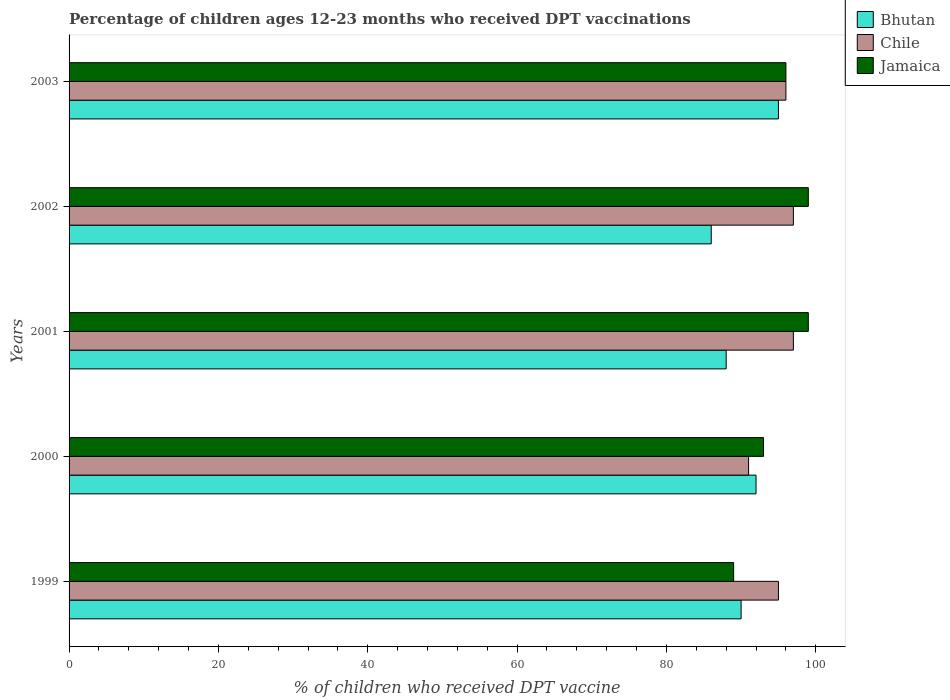How many groups of bars are there?
Offer a terse response. 5. How many bars are there on the 5th tick from the top?
Give a very brief answer. 3. What is the percentage of children who received DPT vaccination in Jamaica in 2001?
Your answer should be compact. 99. Across all years, what is the maximum percentage of children who received DPT vaccination in Jamaica?
Ensure brevity in your answer.  99. Across all years, what is the minimum percentage of children who received DPT vaccination in Chile?
Make the answer very short. 91. In which year was the percentage of children who received DPT vaccination in Bhutan maximum?
Your answer should be very brief. 2003. In which year was the percentage of children who received DPT vaccination in Jamaica minimum?
Your answer should be compact. 1999. What is the total percentage of children who received DPT vaccination in Chile in the graph?
Keep it short and to the point. 476. What is the difference between the percentage of children who received DPT vaccination in Bhutan in 1999 and that in 2000?
Offer a terse response. -2. What is the difference between the percentage of children who received DPT vaccination in Jamaica in 2001 and the percentage of children who received DPT vaccination in Chile in 2003?
Your answer should be compact. 3. What is the average percentage of children who received DPT vaccination in Bhutan per year?
Ensure brevity in your answer.  90.2. In the year 2001, what is the difference between the percentage of children who received DPT vaccination in Bhutan and percentage of children who received DPT vaccination in Chile?
Your answer should be very brief. -9. In how many years, is the percentage of children who received DPT vaccination in Bhutan greater than 68 %?
Make the answer very short. 5. What is the ratio of the percentage of children who received DPT vaccination in Jamaica in 2002 to that in 2003?
Your answer should be compact. 1.03. Is the difference between the percentage of children who received DPT vaccination in Bhutan in 2000 and 2001 greater than the difference between the percentage of children who received DPT vaccination in Chile in 2000 and 2001?
Your answer should be very brief. Yes. What is the difference between the highest and the second highest percentage of children who received DPT vaccination in Chile?
Give a very brief answer. 0. What is the difference between the highest and the lowest percentage of children who received DPT vaccination in Bhutan?
Your answer should be compact. 9. In how many years, is the percentage of children who received DPT vaccination in Bhutan greater than the average percentage of children who received DPT vaccination in Bhutan taken over all years?
Your response must be concise. 2. Is the sum of the percentage of children who received DPT vaccination in Jamaica in 1999 and 2003 greater than the maximum percentage of children who received DPT vaccination in Bhutan across all years?
Your response must be concise. Yes. What does the 2nd bar from the top in 2003 represents?
Provide a short and direct response. Chile. What does the 1st bar from the bottom in 1999 represents?
Your answer should be compact. Bhutan. Is it the case that in every year, the sum of the percentage of children who received DPT vaccination in Bhutan and percentage of children who received DPT vaccination in Jamaica is greater than the percentage of children who received DPT vaccination in Chile?
Provide a succinct answer. Yes. Are all the bars in the graph horizontal?
Your response must be concise. Yes. Are the values on the major ticks of X-axis written in scientific E-notation?
Your response must be concise. No. Does the graph contain grids?
Offer a very short reply. No. Where does the legend appear in the graph?
Offer a terse response. Top right. What is the title of the graph?
Offer a very short reply. Percentage of children ages 12-23 months who received DPT vaccinations. What is the label or title of the X-axis?
Give a very brief answer. % of children who received DPT vaccine. What is the % of children who received DPT vaccine in Jamaica in 1999?
Provide a short and direct response. 89. What is the % of children who received DPT vaccine of Bhutan in 2000?
Give a very brief answer. 92. What is the % of children who received DPT vaccine in Chile in 2000?
Your response must be concise. 91. What is the % of children who received DPT vaccine in Jamaica in 2000?
Keep it short and to the point. 93. What is the % of children who received DPT vaccine in Chile in 2001?
Give a very brief answer. 97. What is the % of children who received DPT vaccine in Jamaica in 2001?
Give a very brief answer. 99. What is the % of children who received DPT vaccine of Bhutan in 2002?
Your response must be concise. 86. What is the % of children who received DPT vaccine of Chile in 2002?
Your response must be concise. 97. What is the % of children who received DPT vaccine of Bhutan in 2003?
Ensure brevity in your answer.  95. What is the % of children who received DPT vaccine in Chile in 2003?
Your answer should be compact. 96. What is the % of children who received DPT vaccine of Jamaica in 2003?
Your response must be concise. 96. Across all years, what is the maximum % of children who received DPT vaccine in Chile?
Your response must be concise. 97. Across all years, what is the maximum % of children who received DPT vaccine in Jamaica?
Provide a short and direct response. 99. Across all years, what is the minimum % of children who received DPT vaccine in Bhutan?
Your answer should be very brief. 86. Across all years, what is the minimum % of children who received DPT vaccine of Chile?
Your answer should be very brief. 91. Across all years, what is the minimum % of children who received DPT vaccine in Jamaica?
Offer a terse response. 89. What is the total % of children who received DPT vaccine in Bhutan in the graph?
Your response must be concise. 451. What is the total % of children who received DPT vaccine of Chile in the graph?
Your answer should be compact. 476. What is the total % of children who received DPT vaccine of Jamaica in the graph?
Offer a terse response. 476. What is the difference between the % of children who received DPT vaccine in Chile in 1999 and that in 2000?
Give a very brief answer. 4. What is the difference between the % of children who received DPT vaccine in Bhutan in 1999 and that in 2001?
Your answer should be very brief. 2. What is the difference between the % of children who received DPT vaccine in Chile in 1999 and that in 2001?
Offer a terse response. -2. What is the difference between the % of children who received DPT vaccine of Bhutan in 1999 and that in 2002?
Provide a short and direct response. 4. What is the difference between the % of children who received DPT vaccine of Chile in 1999 and that in 2002?
Give a very brief answer. -2. What is the difference between the % of children who received DPT vaccine of Jamaica in 1999 and that in 2002?
Provide a short and direct response. -10. What is the difference between the % of children who received DPT vaccine in Bhutan in 1999 and that in 2003?
Make the answer very short. -5. What is the difference between the % of children who received DPT vaccine in Jamaica in 1999 and that in 2003?
Offer a very short reply. -7. What is the difference between the % of children who received DPT vaccine of Jamaica in 2000 and that in 2001?
Your response must be concise. -6. What is the difference between the % of children who received DPT vaccine of Chile in 2000 and that in 2002?
Offer a terse response. -6. What is the difference between the % of children who received DPT vaccine of Jamaica in 2000 and that in 2002?
Keep it short and to the point. -6. What is the difference between the % of children who received DPT vaccine of Bhutan in 2001 and that in 2002?
Your answer should be very brief. 2. What is the difference between the % of children who received DPT vaccine in Jamaica in 2001 and that in 2003?
Your answer should be very brief. 3. What is the difference between the % of children who received DPT vaccine of Bhutan in 2002 and that in 2003?
Provide a succinct answer. -9. What is the difference between the % of children who received DPT vaccine in Chile in 2002 and that in 2003?
Provide a short and direct response. 1. What is the difference between the % of children who received DPT vaccine in Jamaica in 2002 and that in 2003?
Your answer should be compact. 3. What is the difference between the % of children who received DPT vaccine in Bhutan in 1999 and the % of children who received DPT vaccine in Chile in 2000?
Provide a succinct answer. -1. What is the difference between the % of children who received DPT vaccine in Bhutan in 1999 and the % of children who received DPT vaccine in Jamaica in 2000?
Offer a terse response. -3. What is the difference between the % of children who received DPT vaccine in Chile in 1999 and the % of children who received DPT vaccine in Jamaica in 2000?
Provide a short and direct response. 2. What is the difference between the % of children who received DPT vaccine in Bhutan in 1999 and the % of children who received DPT vaccine in Chile in 2002?
Offer a very short reply. -7. What is the difference between the % of children who received DPT vaccine of Chile in 1999 and the % of children who received DPT vaccine of Jamaica in 2002?
Offer a very short reply. -4. What is the difference between the % of children who received DPT vaccine in Chile in 1999 and the % of children who received DPT vaccine in Jamaica in 2003?
Your answer should be very brief. -1. What is the difference between the % of children who received DPT vaccine in Bhutan in 2000 and the % of children who received DPT vaccine in Chile in 2001?
Provide a succinct answer. -5. What is the difference between the % of children who received DPT vaccine of Bhutan in 2000 and the % of children who received DPT vaccine of Jamaica in 2001?
Your answer should be very brief. -7. What is the difference between the % of children who received DPT vaccine in Chile in 2000 and the % of children who received DPT vaccine in Jamaica in 2001?
Make the answer very short. -8. What is the difference between the % of children who received DPT vaccine in Bhutan in 2000 and the % of children who received DPT vaccine in Jamaica in 2002?
Make the answer very short. -7. What is the difference between the % of children who received DPT vaccine in Bhutan in 2001 and the % of children who received DPT vaccine in Chile in 2003?
Provide a short and direct response. -8. What is the difference between the % of children who received DPT vaccine in Chile in 2001 and the % of children who received DPT vaccine in Jamaica in 2003?
Ensure brevity in your answer.  1. What is the difference between the % of children who received DPT vaccine of Bhutan in 2002 and the % of children who received DPT vaccine of Jamaica in 2003?
Your answer should be very brief. -10. What is the average % of children who received DPT vaccine in Bhutan per year?
Offer a terse response. 90.2. What is the average % of children who received DPT vaccine of Chile per year?
Offer a very short reply. 95.2. What is the average % of children who received DPT vaccine of Jamaica per year?
Offer a terse response. 95.2. In the year 1999, what is the difference between the % of children who received DPT vaccine of Bhutan and % of children who received DPT vaccine of Chile?
Provide a short and direct response. -5. In the year 1999, what is the difference between the % of children who received DPT vaccine in Chile and % of children who received DPT vaccine in Jamaica?
Keep it short and to the point. 6. In the year 2000, what is the difference between the % of children who received DPT vaccine of Bhutan and % of children who received DPT vaccine of Chile?
Your answer should be very brief. 1. In the year 2000, what is the difference between the % of children who received DPT vaccine of Chile and % of children who received DPT vaccine of Jamaica?
Make the answer very short. -2. In the year 2001, what is the difference between the % of children who received DPT vaccine in Bhutan and % of children who received DPT vaccine in Chile?
Make the answer very short. -9. In the year 2001, what is the difference between the % of children who received DPT vaccine of Chile and % of children who received DPT vaccine of Jamaica?
Offer a very short reply. -2. In the year 2002, what is the difference between the % of children who received DPT vaccine in Bhutan and % of children who received DPT vaccine in Jamaica?
Offer a terse response. -13. In the year 2003, what is the difference between the % of children who received DPT vaccine of Bhutan and % of children who received DPT vaccine of Chile?
Provide a short and direct response. -1. In the year 2003, what is the difference between the % of children who received DPT vaccine in Bhutan and % of children who received DPT vaccine in Jamaica?
Give a very brief answer. -1. What is the ratio of the % of children who received DPT vaccine of Bhutan in 1999 to that in 2000?
Provide a succinct answer. 0.98. What is the ratio of the % of children who received DPT vaccine of Chile in 1999 to that in 2000?
Make the answer very short. 1.04. What is the ratio of the % of children who received DPT vaccine of Jamaica in 1999 to that in 2000?
Give a very brief answer. 0.96. What is the ratio of the % of children who received DPT vaccine of Bhutan in 1999 to that in 2001?
Give a very brief answer. 1.02. What is the ratio of the % of children who received DPT vaccine of Chile in 1999 to that in 2001?
Provide a short and direct response. 0.98. What is the ratio of the % of children who received DPT vaccine in Jamaica in 1999 to that in 2001?
Your answer should be very brief. 0.9. What is the ratio of the % of children who received DPT vaccine in Bhutan in 1999 to that in 2002?
Your answer should be very brief. 1.05. What is the ratio of the % of children who received DPT vaccine of Chile in 1999 to that in 2002?
Provide a short and direct response. 0.98. What is the ratio of the % of children who received DPT vaccine in Jamaica in 1999 to that in 2002?
Provide a short and direct response. 0.9. What is the ratio of the % of children who received DPT vaccine in Jamaica in 1999 to that in 2003?
Offer a very short reply. 0.93. What is the ratio of the % of children who received DPT vaccine of Bhutan in 2000 to that in 2001?
Your response must be concise. 1.05. What is the ratio of the % of children who received DPT vaccine of Chile in 2000 to that in 2001?
Your answer should be very brief. 0.94. What is the ratio of the % of children who received DPT vaccine in Jamaica in 2000 to that in 2001?
Offer a very short reply. 0.94. What is the ratio of the % of children who received DPT vaccine of Bhutan in 2000 to that in 2002?
Ensure brevity in your answer.  1.07. What is the ratio of the % of children who received DPT vaccine of Chile in 2000 to that in 2002?
Give a very brief answer. 0.94. What is the ratio of the % of children who received DPT vaccine in Jamaica in 2000 to that in 2002?
Keep it short and to the point. 0.94. What is the ratio of the % of children who received DPT vaccine in Bhutan in 2000 to that in 2003?
Give a very brief answer. 0.97. What is the ratio of the % of children who received DPT vaccine of Chile in 2000 to that in 2003?
Your response must be concise. 0.95. What is the ratio of the % of children who received DPT vaccine in Jamaica in 2000 to that in 2003?
Ensure brevity in your answer.  0.97. What is the ratio of the % of children who received DPT vaccine of Bhutan in 2001 to that in 2002?
Keep it short and to the point. 1.02. What is the ratio of the % of children who received DPT vaccine of Chile in 2001 to that in 2002?
Ensure brevity in your answer.  1. What is the ratio of the % of children who received DPT vaccine in Jamaica in 2001 to that in 2002?
Your answer should be very brief. 1. What is the ratio of the % of children who received DPT vaccine of Bhutan in 2001 to that in 2003?
Provide a succinct answer. 0.93. What is the ratio of the % of children who received DPT vaccine of Chile in 2001 to that in 2003?
Make the answer very short. 1.01. What is the ratio of the % of children who received DPT vaccine of Jamaica in 2001 to that in 2003?
Your response must be concise. 1.03. What is the ratio of the % of children who received DPT vaccine of Bhutan in 2002 to that in 2003?
Make the answer very short. 0.91. What is the ratio of the % of children who received DPT vaccine of Chile in 2002 to that in 2003?
Ensure brevity in your answer.  1.01. What is the ratio of the % of children who received DPT vaccine of Jamaica in 2002 to that in 2003?
Offer a very short reply. 1.03. What is the difference between the highest and the lowest % of children who received DPT vaccine in Bhutan?
Your answer should be compact. 9. 